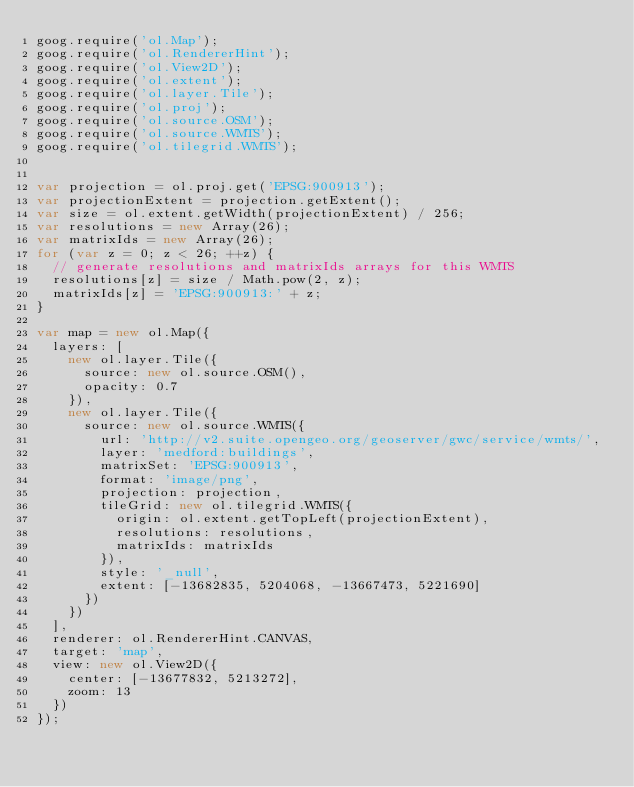Convert code to text. <code><loc_0><loc_0><loc_500><loc_500><_JavaScript_>goog.require('ol.Map');
goog.require('ol.RendererHint');
goog.require('ol.View2D');
goog.require('ol.extent');
goog.require('ol.layer.Tile');
goog.require('ol.proj');
goog.require('ol.source.OSM');
goog.require('ol.source.WMTS');
goog.require('ol.tilegrid.WMTS');


var projection = ol.proj.get('EPSG:900913');
var projectionExtent = projection.getExtent();
var size = ol.extent.getWidth(projectionExtent) / 256;
var resolutions = new Array(26);
var matrixIds = new Array(26);
for (var z = 0; z < 26; ++z) {
  // generate resolutions and matrixIds arrays for this WMTS
  resolutions[z] = size / Math.pow(2, z);
  matrixIds[z] = 'EPSG:900913:' + z;
}

var map = new ol.Map({
  layers: [
    new ol.layer.Tile({
      source: new ol.source.OSM(),
      opacity: 0.7
    }),
    new ol.layer.Tile({
      source: new ol.source.WMTS({
        url: 'http://v2.suite.opengeo.org/geoserver/gwc/service/wmts/',
        layer: 'medford:buildings',
        matrixSet: 'EPSG:900913',
        format: 'image/png',
        projection: projection,
        tileGrid: new ol.tilegrid.WMTS({
          origin: ol.extent.getTopLeft(projectionExtent),
          resolutions: resolutions,
          matrixIds: matrixIds
        }),
        style: '_null',
        extent: [-13682835, 5204068, -13667473, 5221690]
      })
    })
  ],
  renderer: ol.RendererHint.CANVAS,
  target: 'map',
  view: new ol.View2D({
    center: [-13677832, 5213272],
    zoom: 13
  })
});
</code> 